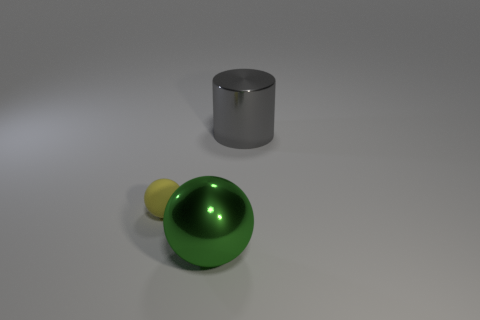Is there anything else that has the same shape as the gray shiny object?
Your response must be concise. No. Is there any other thing that is the same size as the yellow matte thing?
Make the answer very short. No. How many other things are the same color as the metal cylinder?
Offer a terse response. 0. How many objects are objects to the left of the big green sphere or objects on the left side of the large green metal object?
Make the answer very short. 1. Are there fewer small rubber objects than big metal objects?
Provide a succinct answer. Yes. Do the gray thing and the ball left of the big green metallic thing have the same size?
Give a very brief answer. No. What number of rubber objects are either yellow cubes or small objects?
Offer a very short reply. 1. Is the number of large gray shiny spheres greater than the number of big shiny cylinders?
Provide a short and direct response. No. What is the shape of the shiny thing that is in front of the large shiny thing that is behind the green metallic object?
Offer a very short reply. Sphere. There is a shiny thing to the left of the metallic thing behind the yellow ball; is there a rubber ball left of it?
Ensure brevity in your answer.  Yes. 